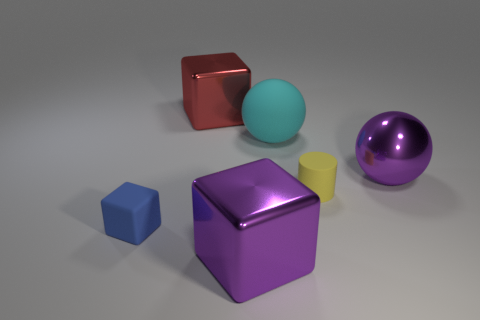Add 3 metal spheres. How many objects exist? 9 Subtract all purple cubes. How many cubes are left? 2 Subtract all cyan spheres. How many spheres are left? 1 Subtract 1 cubes. How many cubes are left? 2 Subtract all cylinders. How many objects are left? 5 Subtract 0 red cylinders. How many objects are left? 6 Subtract all green balls. Subtract all cyan blocks. How many balls are left? 2 Subtract all cyan blocks. How many purple cylinders are left? 0 Subtract all rubber cylinders. Subtract all yellow matte objects. How many objects are left? 4 Add 3 purple metal things. How many purple metal things are left? 5 